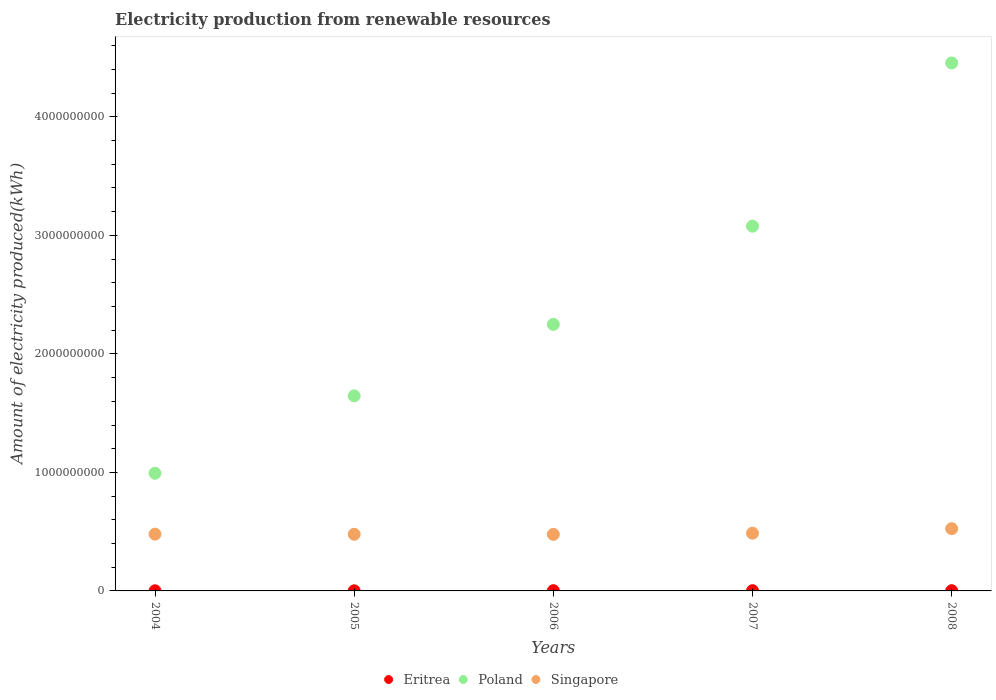Is the number of dotlines equal to the number of legend labels?
Your answer should be compact. Yes. Across all years, what is the maximum amount of electricity produced in Singapore?
Keep it short and to the point. 5.25e+08. Across all years, what is the minimum amount of electricity produced in Poland?
Your answer should be compact. 9.93e+08. In which year was the amount of electricity produced in Eritrea minimum?
Make the answer very short. 2004. What is the difference between the amount of electricity produced in Poland in 2006 and that in 2008?
Your answer should be very brief. -2.21e+09. What is the difference between the amount of electricity produced in Singapore in 2006 and the amount of electricity produced in Eritrea in 2007?
Your answer should be compact. 4.75e+08. What is the average amount of electricity produced in Poland per year?
Your answer should be compact. 2.48e+09. In the year 2006, what is the difference between the amount of electricity produced in Singapore and amount of electricity produced in Poland?
Make the answer very short. -1.77e+09. What is the ratio of the amount of electricity produced in Singapore in 2004 to that in 2007?
Your response must be concise. 0.98. Is the difference between the amount of electricity produced in Singapore in 2004 and 2007 greater than the difference between the amount of electricity produced in Poland in 2004 and 2007?
Your answer should be very brief. Yes. What is the difference between the highest and the lowest amount of electricity produced in Singapore?
Ensure brevity in your answer.  4.80e+07. Is the amount of electricity produced in Poland strictly less than the amount of electricity produced in Singapore over the years?
Offer a terse response. No. How many dotlines are there?
Your answer should be very brief. 3. What is the difference between two consecutive major ticks on the Y-axis?
Your response must be concise. 1.00e+09. Does the graph contain grids?
Your answer should be compact. No. Where does the legend appear in the graph?
Offer a terse response. Bottom center. How are the legend labels stacked?
Provide a short and direct response. Horizontal. What is the title of the graph?
Ensure brevity in your answer.  Electricity production from renewable resources. Does "Arab World" appear as one of the legend labels in the graph?
Provide a short and direct response. No. What is the label or title of the X-axis?
Provide a short and direct response. Years. What is the label or title of the Y-axis?
Offer a very short reply. Amount of electricity produced(kWh). What is the Amount of electricity produced(kWh) in Poland in 2004?
Provide a short and direct response. 9.93e+08. What is the Amount of electricity produced(kWh) in Singapore in 2004?
Your answer should be compact. 4.79e+08. What is the Amount of electricity produced(kWh) of Poland in 2005?
Offer a terse response. 1.65e+09. What is the Amount of electricity produced(kWh) of Singapore in 2005?
Your answer should be very brief. 4.78e+08. What is the Amount of electricity produced(kWh) in Eritrea in 2006?
Provide a short and direct response. 2.00e+06. What is the Amount of electricity produced(kWh) in Poland in 2006?
Your answer should be compact. 2.25e+09. What is the Amount of electricity produced(kWh) of Singapore in 2006?
Your answer should be very brief. 4.77e+08. What is the Amount of electricity produced(kWh) in Poland in 2007?
Make the answer very short. 3.08e+09. What is the Amount of electricity produced(kWh) in Singapore in 2007?
Offer a very short reply. 4.87e+08. What is the Amount of electricity produced(kWh) of Poland in 2008?
Ensure brevity in your answer.  4.46e+09. What is the Amount of electricity produced(kWh) of Singapore in 2008?
Provide a short and direct response. 5.25e+08. Across all years, what is the maximum Amount of electricity produced(kWh) of Eritrea?
Ensure brevity in your answer.  2.00e+06. Across all years, what is the maximum Amount of electricity produced(kWh) in Poland?
Provide a short and direct response. 4.46e+09. Across all years, what is the maximum Amount of electricity produced(kWh) in Singapore?
Keep it short and to the point. 5.25e+08. Across all years, what is the minimum Amount of electricity produced(kWh) of Poland?
Keep it short and to the point. 9.93e+08. Across all years, what is the minimum Amount of electricity produced(kWh) in Singapore?
Provide a succinct answer. 4.77e+08. What is the total Amount of electricity produced(kWh) in Eritrea in the graph?
Make the answer very short. 8.00e+06. What is the total Amount of electricity produced(kWh) of Poland in the graph?
Your answer should be very brief. 1.24e+1. What is the total Amount of electricity produced(kWh) in Singapore in the graph?
Keep it short and to the point. 2.45e+09. What is the difference between the Amount of electricity produced(kWh) of Poland in 2004 and that in 2005?
Make the answer very short. -6.53e+08. What is the difference between the Amount of electricity produced(kWh) of Poland in 2004 and that in 2006?
Your answer should be very brief. -1.26e+09. What is the difference between the Amount of electricity produced(kWh) in Singapore in 2004 and that in 2006?
Your answer should be compact. 2.00e+06. What is the difference between the Amount of electricity produced(kWh) of Poland in 2004 and that in 2007?
Make the answer very short. -2.08e+09. What is the difference between the Amount of electricity produced(kWh) of Singapore in 2004 and that in 2007?
Offer a terse response. -8.00e+06. What is the difference between the Amount of electricity produced(kWh) of Poland in 2004 and that in 2008?
Make the answer very short. -3.46e+09. What is the difference between the Amount of electricity produced(kWh) in Singapore in 2004 and that in 2008?
Keep it short and to the point. -4.60e+07. What is the difference between the Amount of electricity produced(kWh) of Eritrea in 2005 and that in 2006?
Your answer should be compact. -1.00e+06. What is the difference between the Amount of electricity produced(kWh) in Poland in 2005 and that in 2006?
Offer a terse response. -6.03e+08. What is the difference between the Amount of electricity produced(kWh) in Singapore in 2005 and that in 2006?
Your answer should be compact. 1.00e+06. What is the difference between the Amount of electricity produced(kWh) of Poland in 2005 and that in 2007?
Your answer should be very brief. -1.43e+09. What is the difference between the Amount of electricity produced(kWh) of Singapore in 2005 and that in 2007?
Keep it short and to the point. -9.00e+06. What is the difference between the Amount of electricity produced(kWh) of Eritrea in 2005 and that in 2008?
Your answer should be compact. -1.00e+06. What is the difference between the Amount of electricity produced(kWh) of Poland in 2005 and that in 2008?
Provide a short and direct response. -2.81e+09. What is the difference between the Amount of electricity produced(kWh) of Singapore in 2005 and that in 2008?
Your response must be concise. -4.70e+07. What is the difference between the Amount of electricity produced(kWh) in Poland in 2006 and that in 2007?
Provide a succinct answer. -8.29e+08. What is the difference between the Amount of electricity produced(kWh) in Singapore in 2006 and that in 2007?
Keep it short and to the point. -1.00e+07. What is the difference between the Amount of electricity produced(kWh) in Poland in 2006 and that in 2008?
Your response must be concise. -2.21e+09. What is the difference between the Amount of electricity produced(kWh) of Singapore in 2006 and that in 2008?
Keep it short and to the point. -4.80e+07. What is the difference between the Amount of electricity produced(kWh) in Poland in 2007 and that in 2008?
Your response must be concise. -1.38e+09. What is the difference between the Amount of electricity produced(kWh) in Singapore in 2007 and that in 2008?
Offer a very short reply. -3.80e+07. What is the difference between the Amount of electricity produced(kWh) in Eritrea in 2004 and the Amount of electricity produced(kWh) in Poland in 2005?
Provide a succinct answer. -1.64e+09. What is the difference between the Amount of electricity produced(kWh) in Eritrea in 2004 and the Amount of electricity produced(kWh) in Singapore in 2005?
Offer a terse response. -4.77e+08. What is the difference between the Amount of electricity produced(kWh) of Poland in 2004 and the Amount of electricity produced(kWh) of Singapore in 2005?
Keep it short and to the point. 5.15e+08. What is the difference between the Amount of electricity produced(kWh) of Eritrea in 2004 and the Amount of electricity produced(kWh) of Poland in 2006?
Provide a short and direct response. -2.25e+09. What is the difference between the Amount of electricity produced(kWh) in Eritrea in 2004 and the Amount of electricity produced(kWh) in Singapore in 2006?
Give a very brief answer. -4.76e+08. What is the difference between the Amount of electricity produced(kWh) in Poland in 2004 and the Amount of electricity produced(kWh) in Singapore in 2006?
Make the answer very short. 5.16e+08. What is the difference between the Amount of electricity produced(kWh) of Eritrea in 2004 and the Amount of electricity produced(kWh) of Poland in 2007?
Provide a succinct answer. -3.08e+09. What is the difference between the Amount of electricity produced(kWh) of Eritrea in 2004 and the Amount of electricity produced(kWh) of Singapore in 2007?
Provide a short and direct response. -4.86e+08. What is the difference between the Amount of electricity produced(kWh) in Poland in 2004 and the Amount of electricity produced(kWh) in Singapore in 2007?
Ensure brevity in your answer.  5.06e+08. What is the difference between the Amount of electricity produced(kWh) of Eritrea in 2004 and the Amount of electricity produced(kWh) of Poland in 2008?
Your response must be concise. -4.45e+09. What is the difference between the Amount of electricity produced(kWh) in Eritrea in 2004 and the Amount of electricity produced(kWh) in Singapore in 2008?
Offer a terse response. -5.24e+08. What is the difference between the Amount of electricity produced(kWh) of Poland in 2004 and the Amount of electricity produced(kWh) of Singapore in 2008?
Your response must be concise. 4.68e+08. What is the difference between the Amount of electricity produced(kWh) of Eritrea in 2005 and the Amount of electricity produced(kWh) of Poland in 2006?
Give a very brief answer. -2.25e+09. What is the difference between the Amount of electricity produced(kWh) in Eritrea in 2005 and the Amount of electricity produced(kWh) in Singapore in 2006?
Ensure brevity in your answer.  -4.76e+08. What is the difference between the Amount of electricity produced(kWh) of Poland in 2005 and the Amount of electricity produced(kWh) of Singapore in 2006?
Provide a short and direct response. 1.17e+09. What is the difference between the Amount of electricity produced(kWh) in Eritrea in 2005 and the Amount of electricity produced(kWh) in Poland in 2007?
Keep it short and to the point. -3.08e+09. What is the difference between the Amount of electricity produced(kWh) in Eritrea in 2005 and the Amount of electricity produced(kWh) in Singapore in 2007?
Offer a very short reply. -4.86e+08. What is the difference between the Amount of electricity produced(kWh) in Poland in 2005 and the Amount of electricity produced(kWh) in Singapore in 2007?
Provide a succinct answer. 1.16e+09. What is the difference between the Amount of electricity produced(kWh) in Eritrea in 2005 and the Amount of electricity produced(kWh) in Poland in 2008?
Offer a very short reply. -4.45e+09. What is the difference between the Amount of electricity produced(kWh) in Eritrea in 2005 and the Amount of electricity produced(kWh) in Singapore in 2008?
Ensure brevity in your answer.  -5.24e+08. What is the difference between the Amount of electricity produced(kWh) of Poland in 2005 and the Amount of electricity produced(kWh) of Singapore in 2008?
Your answer should be very brief. 1.12e+09. What is the difference between the Amount of electricity produced(kWh) of Eritrea in 2006 and the Amount of electricity produced(kWh) of Poland in 2007?
Make the answer very short. -3.08e+09. What is the difference between the Amount of electricity produced(kWh) in Eritrea in 2006 and the Amount of electricity produced(kWh) in Singapore in 2007?
Provide a succinct answer. -4.85e+08. What is the difference between the Amount of electricity produced(kWh) of Poland in 2006 and the Amount of electricity produced(kWh) of Singapore in 2007?
Make the answer very short. 1.76e+09. What is the difference between the Amount of electricity produced(kWh) in Eritrea in 2006 and the Amount of electricity produced(kWh) in Poland in 2008?
Ensure brevity in your answer.  -4.45e+09. What is the difference between the Amount of electricity produced(kWh) of Eritrea in 2006 and the Amount of electricity produced(kWh) of Singapore in 2008?
Provide a succinct answer. -5.23e+08. What is the difference between the Amount of electricity produced(kWh) of Poland in 2006 and the Amount of electricity produced(kWh) of Singapore in 2008?
Keep it short and to the point. 1.72e+09. What is the difference between the Amount of electricity produced(kWh) of Eritrea in 2007 and the Amount of electricity produced(kWh) of Poland in 2008?
Offer a terse response. -4.45e+09. What is the difference between the Amount of electricity produced(kWh) in Eritrea in 2007 and the Amount of electricity produced(kWh) in Singapore in 2008?
Make the answer very short. -5.23e+08. What is the difference between the Amount of electricity produced(kWh) of Poland in 2007 and the Amount of electricity produced(kWh) of Singapore in 2008?
Your answer should be very brief. 2.55e+09. What is the average Amount of electricity produced(kWh) in Eritrea per year?
Ensure brevity in your answer.  1.60e+06. What is the average Amount of electricity produced(kWh) in Poland per year?
Your answer should be very brief. 2.48e+09. What is the average Amount of electricity produced(kWh) in Singapore per year?
Give a very brief answer. 4.89e+08. In the year 2004, what is the difference between the Amount of electricity produced(kWh) in Eritrea and Amount of electricity produced(kWh) in Poland?
Make the answer very short. -9.92e+08. In the year 2004, what is the difference between the Amount of electricity produced(kWh) of Eritrea and Amount of electricity produced(kWh) of Singapore?
Offer a very short reply. -4.78e+08. In the year 2004, what is the difference between the Amount of electricity produced(kWh) in Poland and Amount of electricity produced(kWh) in Singapore?
Your response must be concise. 5.14e+08. In the year 2005, what is the difference between the Amount of electricity produced(kWh) in Eritrea and Amount of electricity produced(kWh) in Poland?
Make the answer very short. -1.64e+09. In the year 2005, what is the difference between the Amount of electricity produced(kWh) of Eritrea and Amount of electricity produced(kWh) of Singapore?
Offer a very short reply. -4.77e+08. In the year 2005, what is the difference between the Amount of electricity produced(kWh) in Poland and Amount of electricity produced(kWh) in Singapore?
Ensure brevity in your answer.  1.17e+09. In the year 2006, what is the difference between the Amount of electricity produced(kWh) of Eritrea and Amount of electricity produced(kWh) of Poland?
Your answer should be compact. -2.25e+09. In the year 2006, what is the difference between the Amount of electricity produced(kWh) of Eritrea and Amount of electricity produced(kWh) of Singapore?
Keep it short and to the point. -4.75e+08. In the year 2006, what is the difference between the Amount of electricity produced(kWh) in Poland and Amount of electricity produced(kWh) in Singapore?
Keep it short and to the point. 1.77e+09. In the year 2007, what is the difference between the Amount of electricity produced(kWh) in Eritrea and Amount of electricity produced(kWh) in Poland?
Ensure brevity in your answer.  -3.08e+09. In the year 2007, what is the difference between the Amount of electricity produced(kWh) in Eritrea and Amount of electricity produced(kWh) in Singapore?
Ensure brevity in your answer.  -4.85e+08. In the year 2007, what is the difference between the Amount of electricity produced(kWh) in Poland and Amount of electricity produced(kWh) in Singapore?
Provide a succinct answer. 2.59e+09. In the year 2008, what is the difference between the Amount of electricity produced(kWh) in Eritrea and Amount of electricity produced(kWh) in Poland?
Your answer should be compact. -4.45e+09. In the year 2008, what is the difference between the Amount of electricity produced(kWh) in Eritrea and Amount of electricity produced(kWh) in Singapore?
Keep it short and to the point. -5.23e+08. In the year 2008, what is the difference between the Amount of electricity produced(kWh) of Poland and Amount of electricity produced(kWh) of Singapore?
Your response must be concise. 3.93e+09. What is the ratio of the Amount of electricity produced(kWh) of Eritrea in 2004 to that in 2005?
Your answer should be very brief. 1. What is the ratio of the Amount of electricity produced(kWh) in Poland in 2004 to that in 2005?
Offer a terse response. 0.6. What is the ratio of the Amount of electricity produced(kWh) in Eritrea in 2004 to that in 2006?
Make the answer very short. 0.5. What is the ratio of the Amount of electricity produced(kWh) of Poland in 2004 to that in 2006?
Ensure brevity in your answer.  0.44. What is the ratio of the Amount of electricity produced(kWh) in Singapore in 2004 to that in 2006?
Provide a succinct answer. 1. What is the ratio of the Amount of electricity produced(kWh) of Poland in 2004 to that in 2007?
Your response must be concise. 0.32. What is the ratio of the Amount of electricity produced(kWh) of Singapore in 2004 to that in 2007?
Your answer should be compact. 0.98. What is the ratio of the Amount of electricity produced(kWh) of Eritrea in 2004 to that in 2008?
Offer a terse response. 0.5. What is the ratio of the Amount of electricity produced(kWh) of Poland in 2004 to that in 2008?
Keep it short and to the point. 0.22. What is the ratio of the Amount of electricity produced(kWh) of Singapore in 2004 to that in 2008?
Make the answer very short. 0.91. What is the ratio of the Amount of electricity produced(kWh) of Eritrea in 2005 to that in 2006?
Your answer should be very brief. 0.5. What is the ratio of the Amount of electricity produced(kWh) of Poland in 2005 to that in 2006?
Provide a succinct answer. 0.73. What is the ratio of the Amount of electricity produced(kWh) of Singapore in 2005 to that in 2006?
Ensure brevity in your answer.  1. What is the ratio of the Amount of electricity produced(kWh) of Poland in 2005 to that in 2007?
Give a very brief answer. 0.53. What is the ratio of the Amount of electricity produced(kWh) in Singapore in 2005 to that in 2007?
Your answer should be very brief. 0.98. What is the ratio of the Amount of electricity produced(kWh) of Eritrea in 2005 to that in 2008?
Your answer should be very brief. 0.5. What is the ratio of the Amount of electricity produced(kWh) of Poland in 2005 to that in 2008?
Give a very brief answer. 0.37. What is the ratio of the Amount of electricity produced(kWh) in Singapore in 2005 to that in 2008?
Provide a short and direct response. 0.91. What is the ratio of the Amount of electricity produced(kWh) of Poland in 2006 to that in 2007?
Your response must be concise. 0.73. What is the ratio of the Amount of electricity produced(kWh) in Singapore in 2006 to that in 2007?
Your answer should be compact. 0.98. What is the ratio of the Amount of electricity produced(kWh) of Eritrea in 2006 to that in 2008?
Offer a very short reply. 1. What is the ratio of the Amount of electricity produced(kWh) in Poland in 2006 to that in 2008?
Keep it short and to the point. 0.5. What is the ratio of the Amount of electricity produced(kWh) of Singapore in 2006 to that in 2008?
Make the answer very short. 0.91. What is the ratio of the Amount of electricity produced(kWh) in Eritrea in 2007 to that in 2008?
Make the answer very short. 1. What is the ratio of the Amount of electricity produced(kWh) of Poland in 2007 to that in 2008?
Give a very brief answer. 0.69. What is the ratio of the Amount of electricity produced(kWh) in Singapore in 2007 to that in 2008?
Ensure brevity in your answer.  0.93. What is the difference between the highest and the second highest Amount of electricity produced(kWh) of Eritrea?
Offer a very short reply. 0. What is the difference between the highest and the second highest Amount of electricity produced(kWh) of Poland?
Ensure brevity in your answer.  1.38e+09. What is the difference between the highest and the second highest Amount of electricity produced(kWh) in Singapore?
Offer a very short reply. 3.80e+07. What is the difference between the highest and the lowest Amount of electricity produced(kWh) of Poland?
Make the answer very short. 3.46e+09. What is the difference between the highest and the lowest Amount of electricity produced(kWh) in Singapore?
Provide a succinct answer. 4.80e+07. 